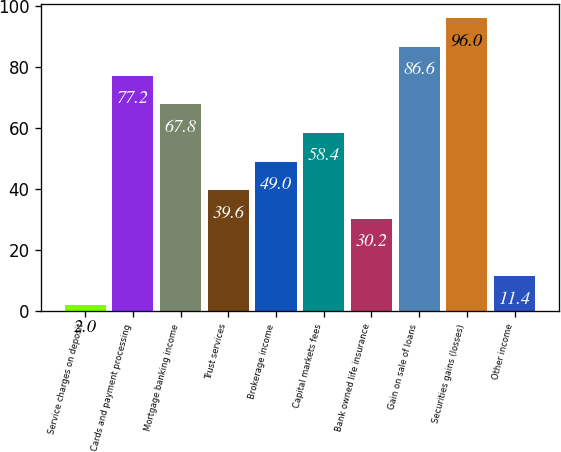<chart> <loc_0><loc_0><loc_500><loc_500><bar_chart><fcel>Service charges on deposit<fcel>Cards and payment processing<fcel>Mortgage banking income<fcel>Trust services<fcel>Brokerage income<fcel>Capital markets fees<fcel>Bank owned life insurance<fcel>Gain on sale of loans<fcel>Securities gains (losses)<fcel>Other income<nl><fcel>2<fcel>77.2<fcel>67.8<fcel>39.6<fcel>49<fcel>58.4<fcel>30.2<fcel>86.6<fcel>96<fcel>11.4<nl></chart> 